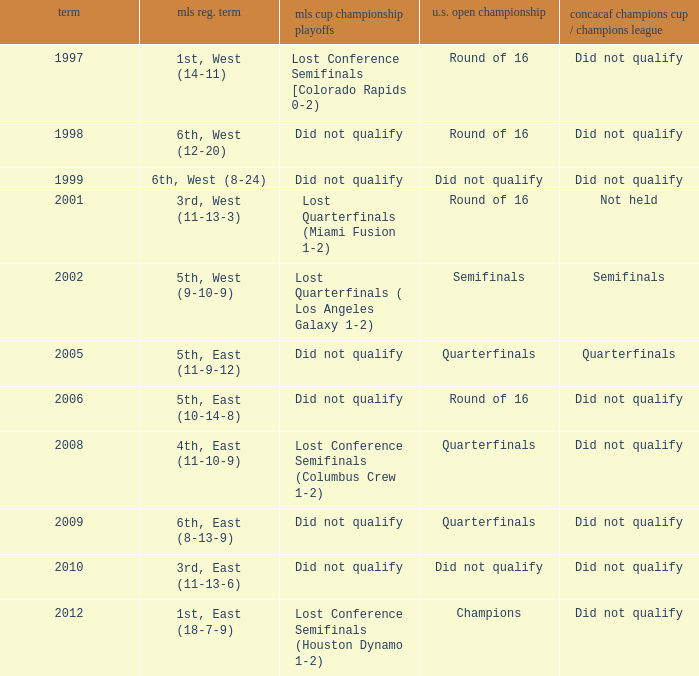When was the first season? 1997.0. 